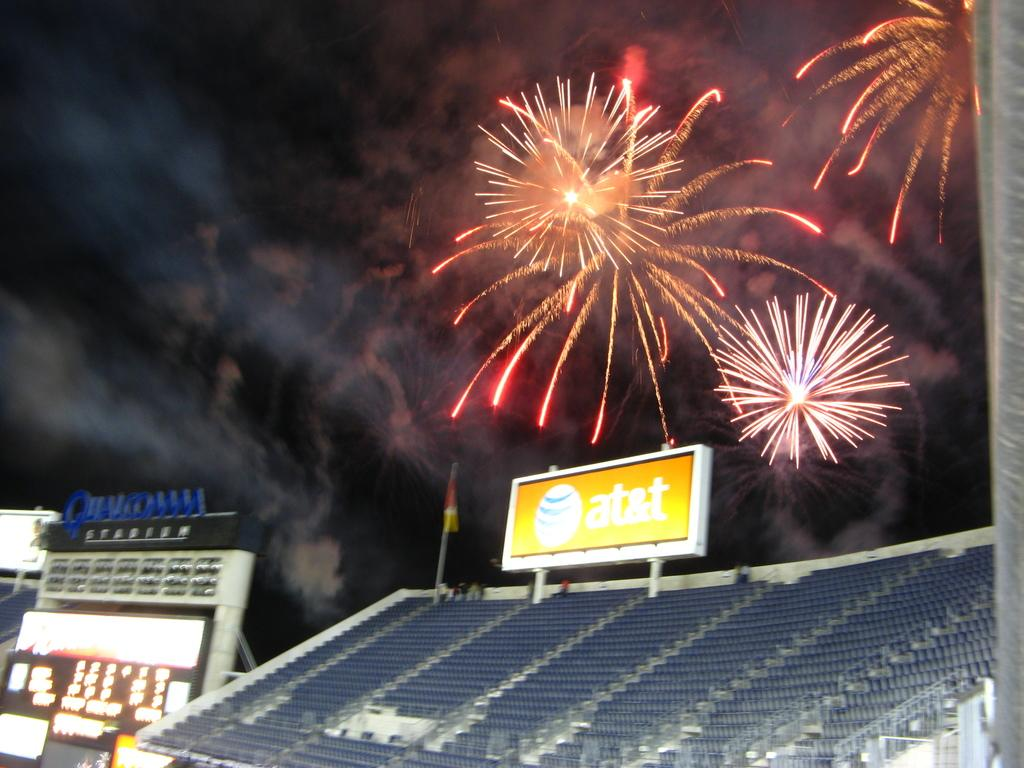<image>
Write a terse but informative summary of the picture. Fireworks explode in the sky above Qualcomm Stadium. 